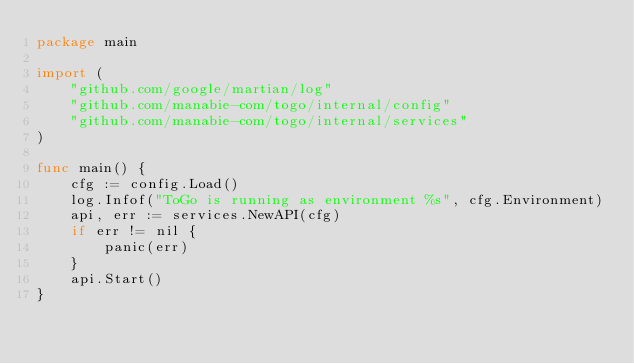Convert code to text. <code><loc_0><loc_0><loc_500><loc_500><_Go_>package main

import (
	"github.com/google/martian/log"
	"github.com/manabie-com/togo/internal/config"
	"github.com/manabie-com/togo/internal/services"
)

func main() {
	cfg := config.Load()
	log.Infof("ToGo is running as environment %s", cfg.Environment)
	api, err := services.NewAPI(cfg)
	if err != nil {
		panic(err)
	}
	api.Start()
}
</code> 